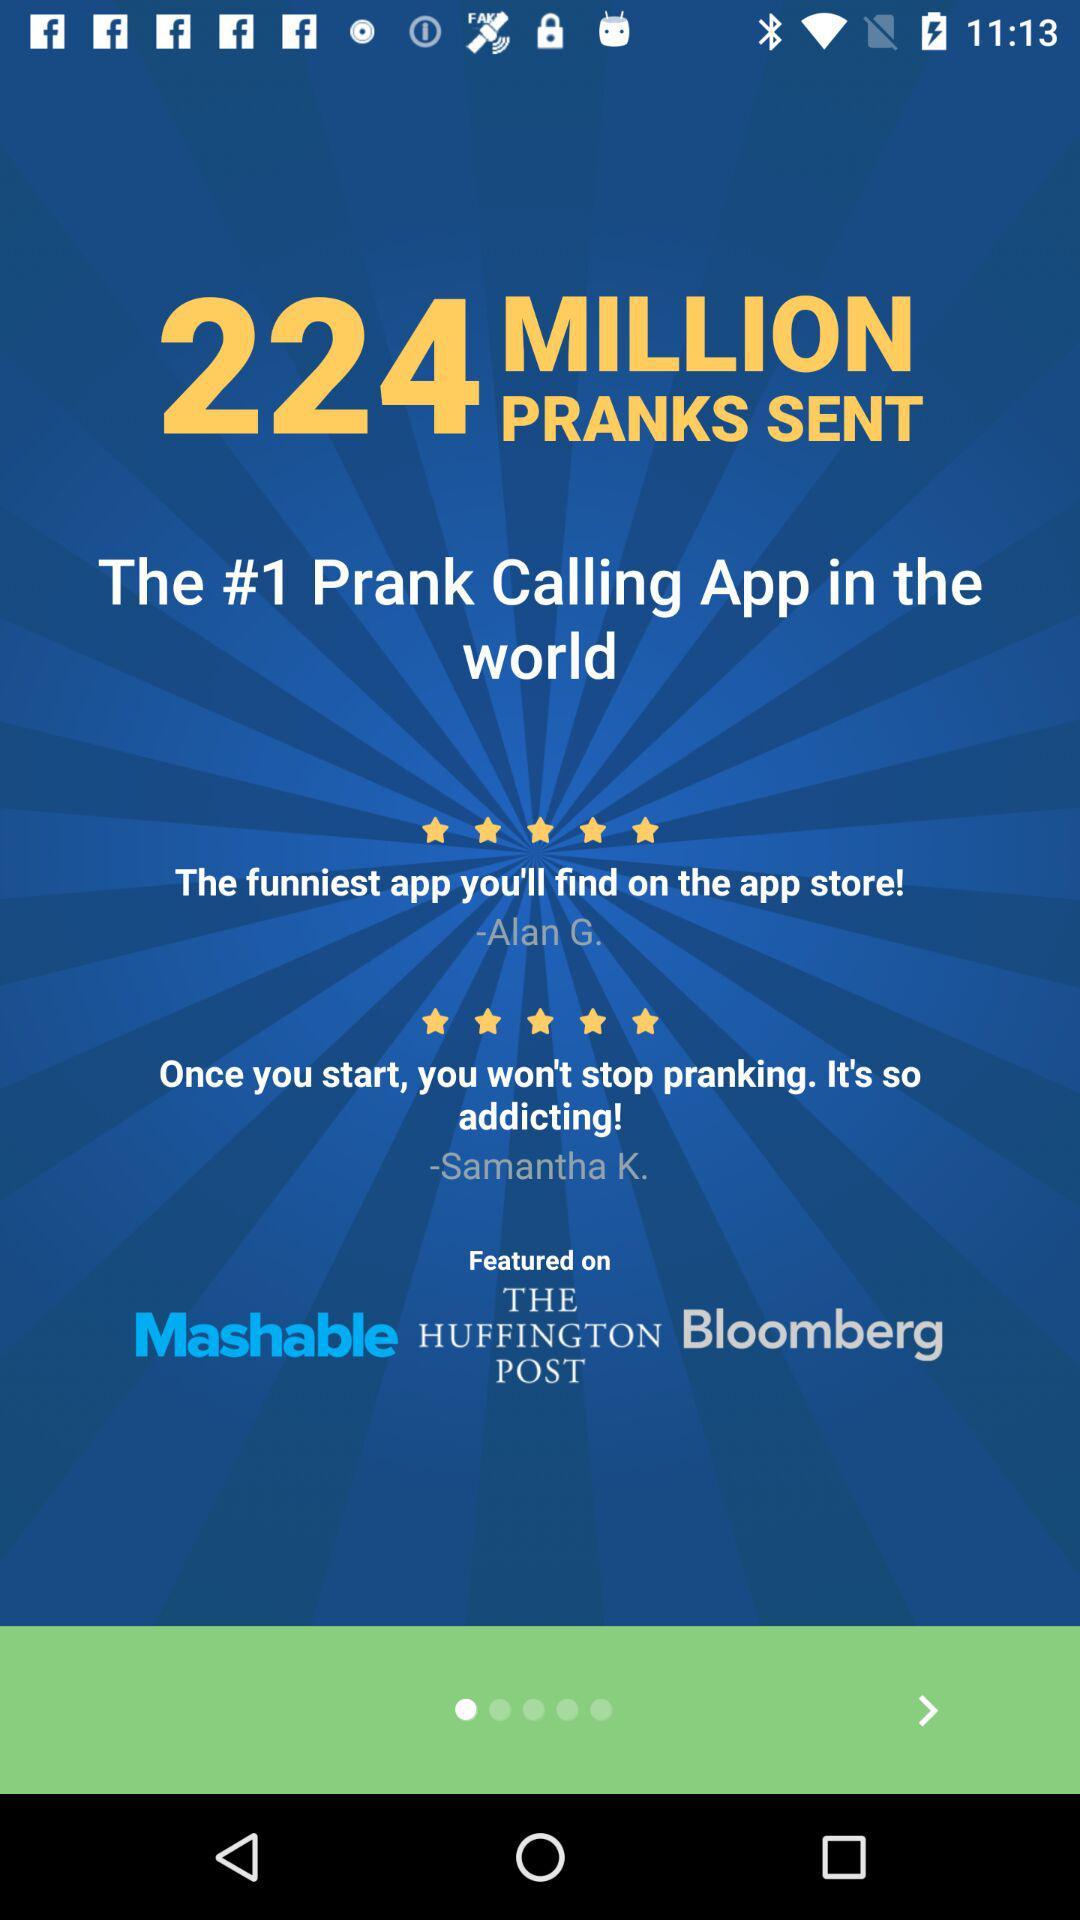How many parks are there?
When the provided information is insufficient, respond with <no answer>. <no answer> 